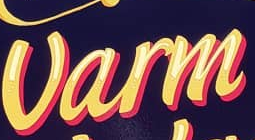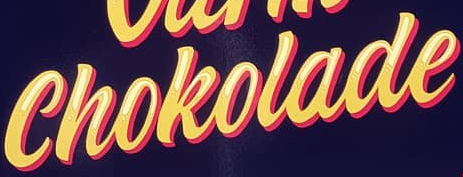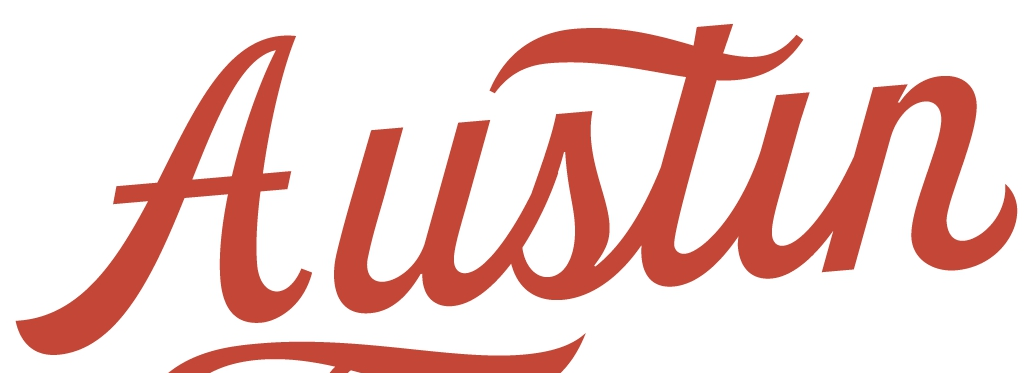What words are shown in these images in order, separated by a semicolon? Varm; Chokolade; Austin 